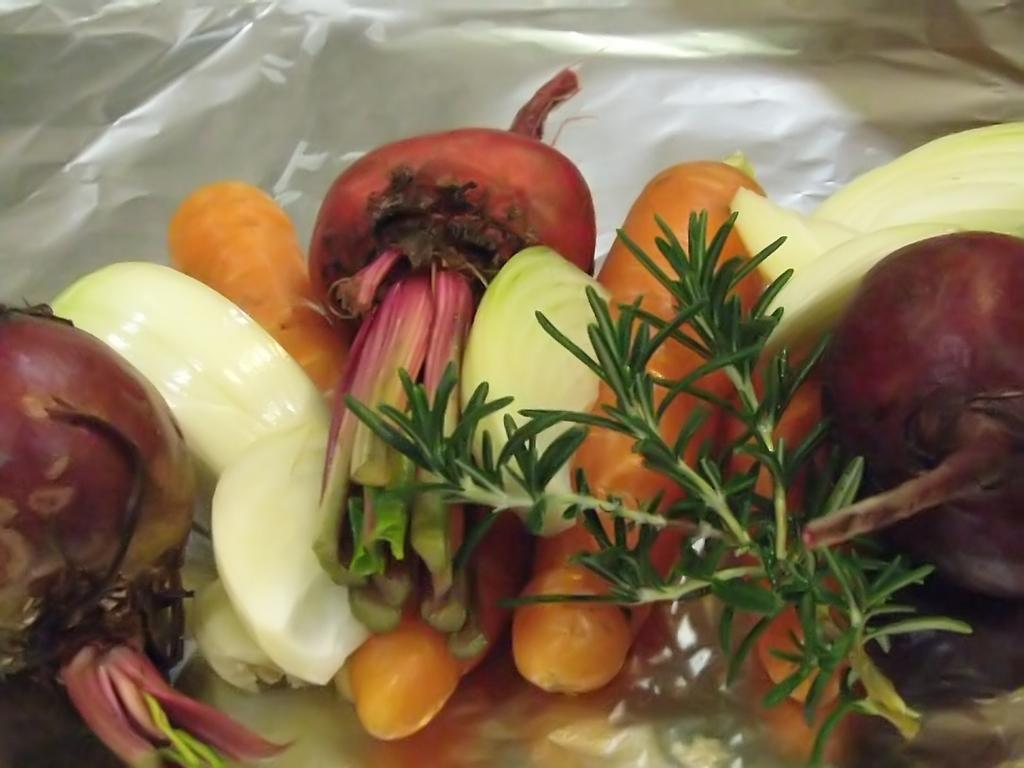What type of food items can be seen in the image? There are vegetables in the image. How are the vegetables arranged or presented? The vegetables are on a silver foil. Can you hear the vegetables crying in the image? There is no sound or indication of crying in the image, as it only shows vegetables on a silver foil. 